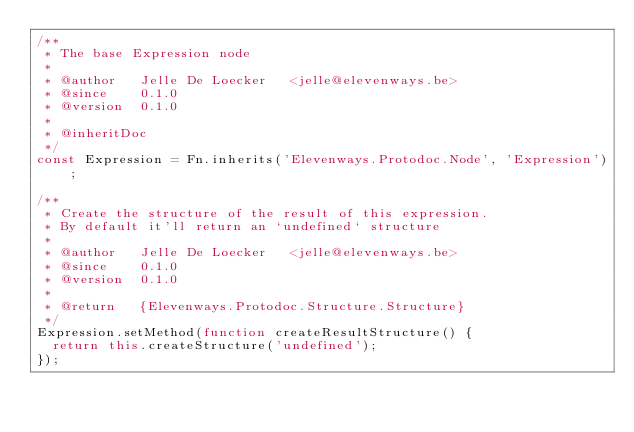Convert code to text. <code><loc_0><loc_0><loc_500><loc_500><_JavaScript_>/**
 * The base Expression node
 *
 * @author   Jelle De Loecker   <jelle@elevenways.be>
 * @since    0.1.0
 * @version  0.1.0
 *
 * @inheritDoc
 */
const Expression = Fn.inherits('Elevenways.Protodoc.Node', 'Expression');

/**
 * Create the structure of the result of this expression.
 * By default it'll return an `undefined` structure
 *
 * @author   Jelle De Loecker   <jelle@elevenways.be>
 * @since    0.1.0
 * @version  0.1.0
 *
 * @return   {Elevenways.Protodoc.Structure.Structure}
 */
Expression.setMethod(function createResultStructure() {
	return this.createStructure('undefined');
});</code> 